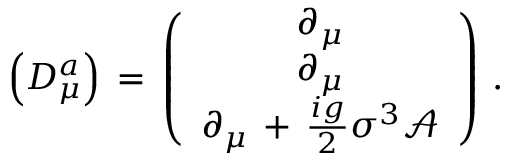<formula> <loc_0><loc_0><loc_500><loc_500>\left ( D _ { \mu } ^ { a } \right ) \, = \, \left ( \begin{array} { c } { { \partial _ { \mu } } } \\ { { \partial _ { \mu } } } \\ { { \partial _ { \mu } \, + \, \frac { i g } { 2 } \sigma ^ { 3 } \mathcal { A } } } \end{array} \right ) \, .</formula> 